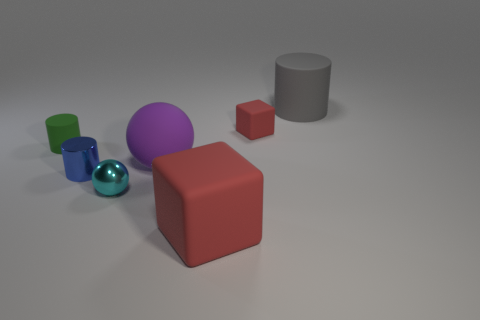Add 1 tiny yellow matte blocks. How many objects exist? 8 Subtract all rubber cylinders. How many cylinders are left? 1 Subtract all cyan spheres. How many spheres are left? 1 Subtract all balls. How many objects are left? 5 Add 3 purple spheres. How many purple spheres are left? 4 Add 2 metallic objects. How many metallic objects exist? 4 Subtract 0 brown cylinders. How many objects are left? 7 Subtract 1 balls. How many balls are left? 1 Subtract all green blocks. Subtract all blue cylinders. How many blocks are left? 2 Subtract all green cylinders. How many purple spheres are left? 1 